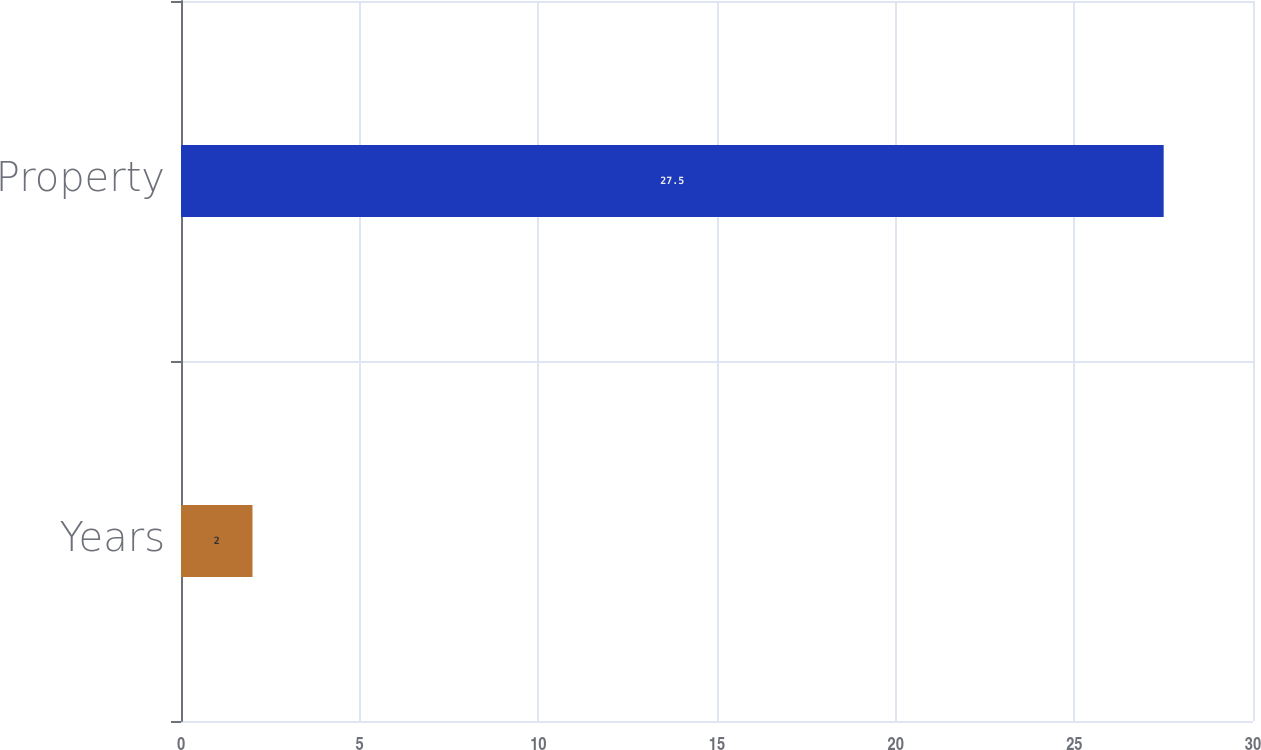Convert chart to OTSL. <chart><loc_0><loc_0><loc_500><loc_500><bar_chart><fcel>Years<fcel>Property<nl><fcel>2<fcel>27.5<nl></chart> 